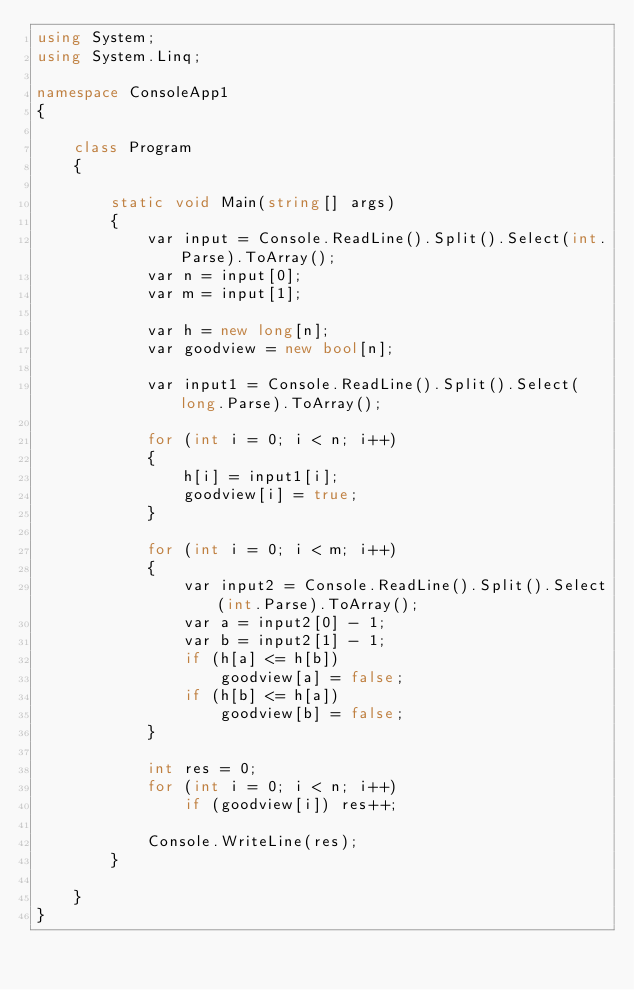<code> <loc_0><loc_0><loc_500><loc_500><_C#_>using System;
using System.Linq;

namespace ConsoleApp1
{

    class Program
    {

        static void Main(string[] args)
        {
            var input = Console.ReadLine().Split().Select(int.Parse).ToArray();
            var n = input[0];
            var m = input[1];

            var h = new long[n];
            var goodview = new bool[n];

            var input1 = Console.ReadLine().Split().Select(long.Parse).ToArray();

            for (int i = 0; i < n; i++)
            {
                h[i] = input1[i];
                goodview[i] = true;
            }

            for (int i = 0; i < m; i++)
            {
                var input2 = Console.ReadLine().Split().Select(int.Parse).ToArray();
                var a = input2[0] - 1;
                var b = input2[1] - 1;
                if (h[a] <= h[b])
                    goodview[a] = false;
                if (h[b] <= h[a])
                    goodview[b] = false;
            }

            int res = 0;
            for (int i = 0; i < n; i++)
                if (goodview[i]) res++;

            Console.WriteLine(res);
        }

    }
}

</code> 